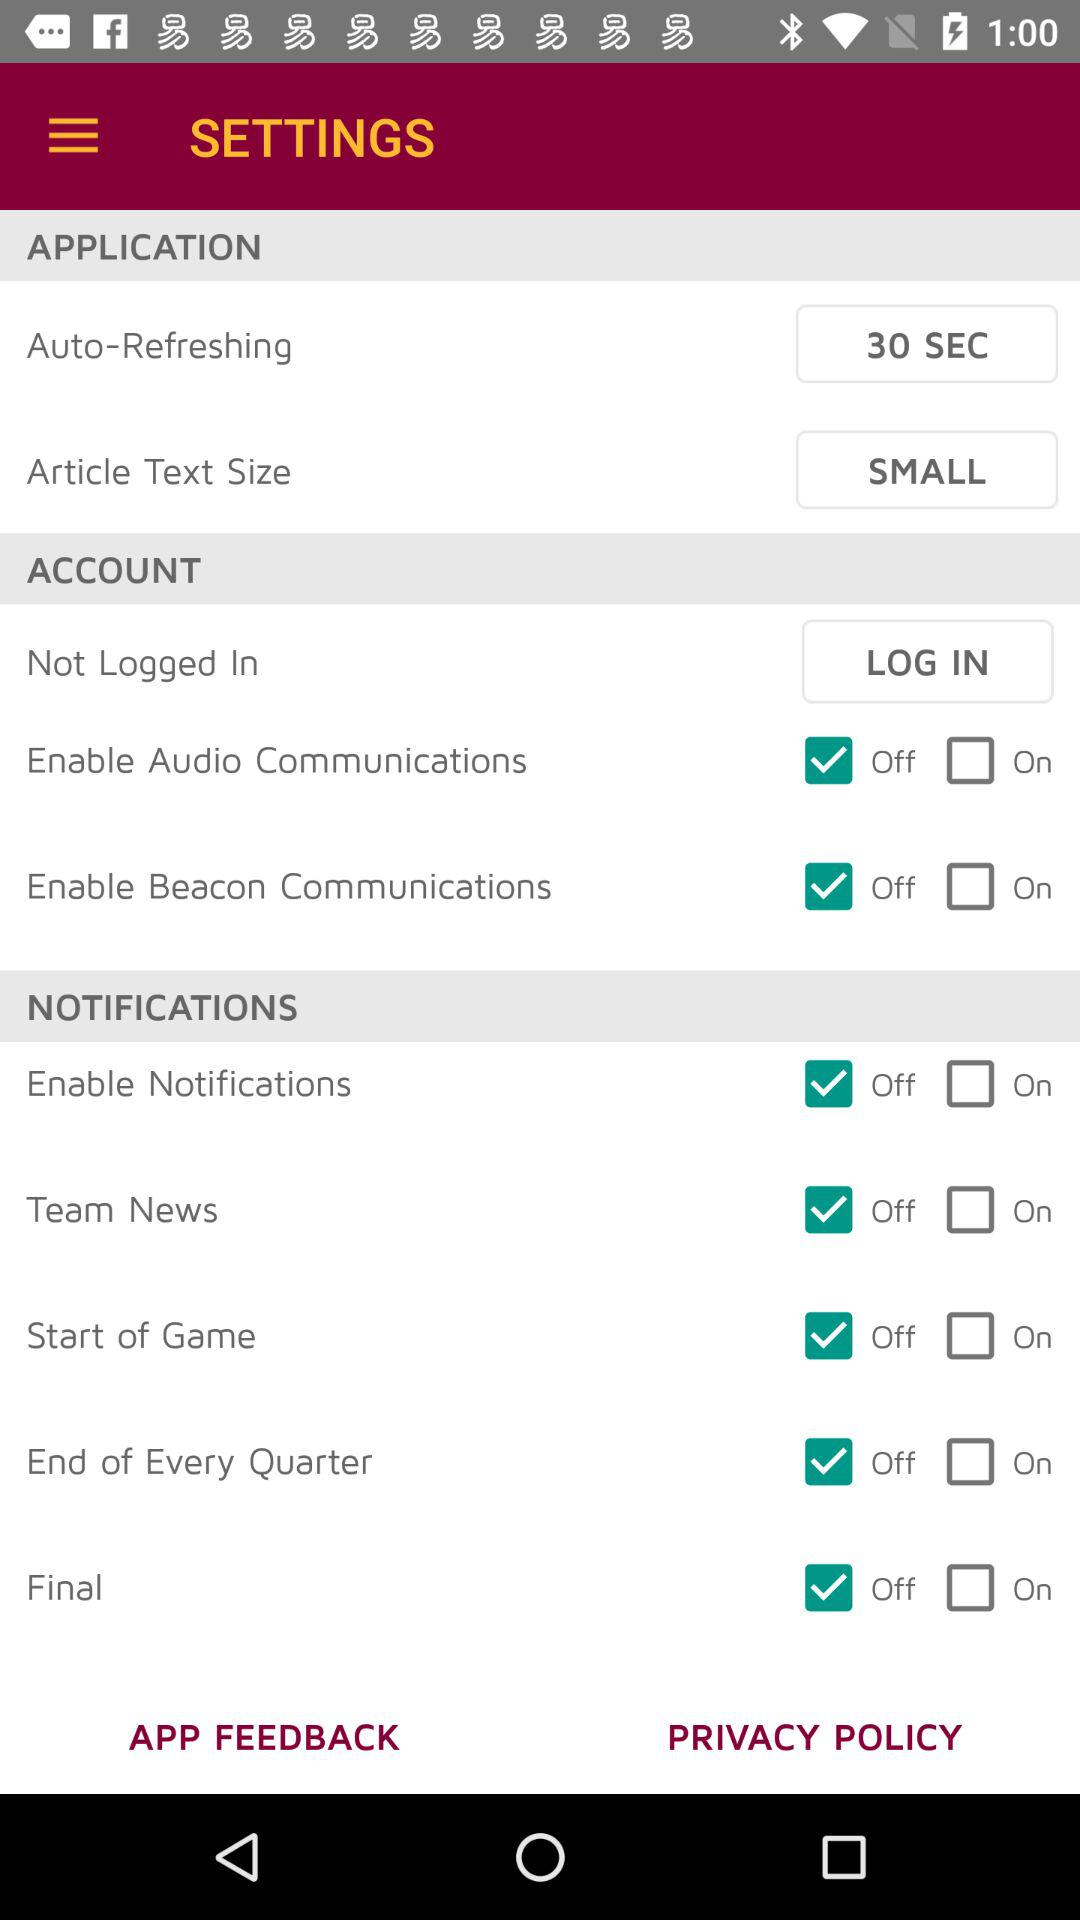What is the article text size in the "APPLICATION"? The article text size is small. 